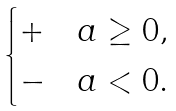Convert formula to latex. <formula><loc_0><loc_0><loc_500><loc_500>\begin{cases} + & a \geq 0 , \\ - & a < 0 . \end{cases}</formula> 